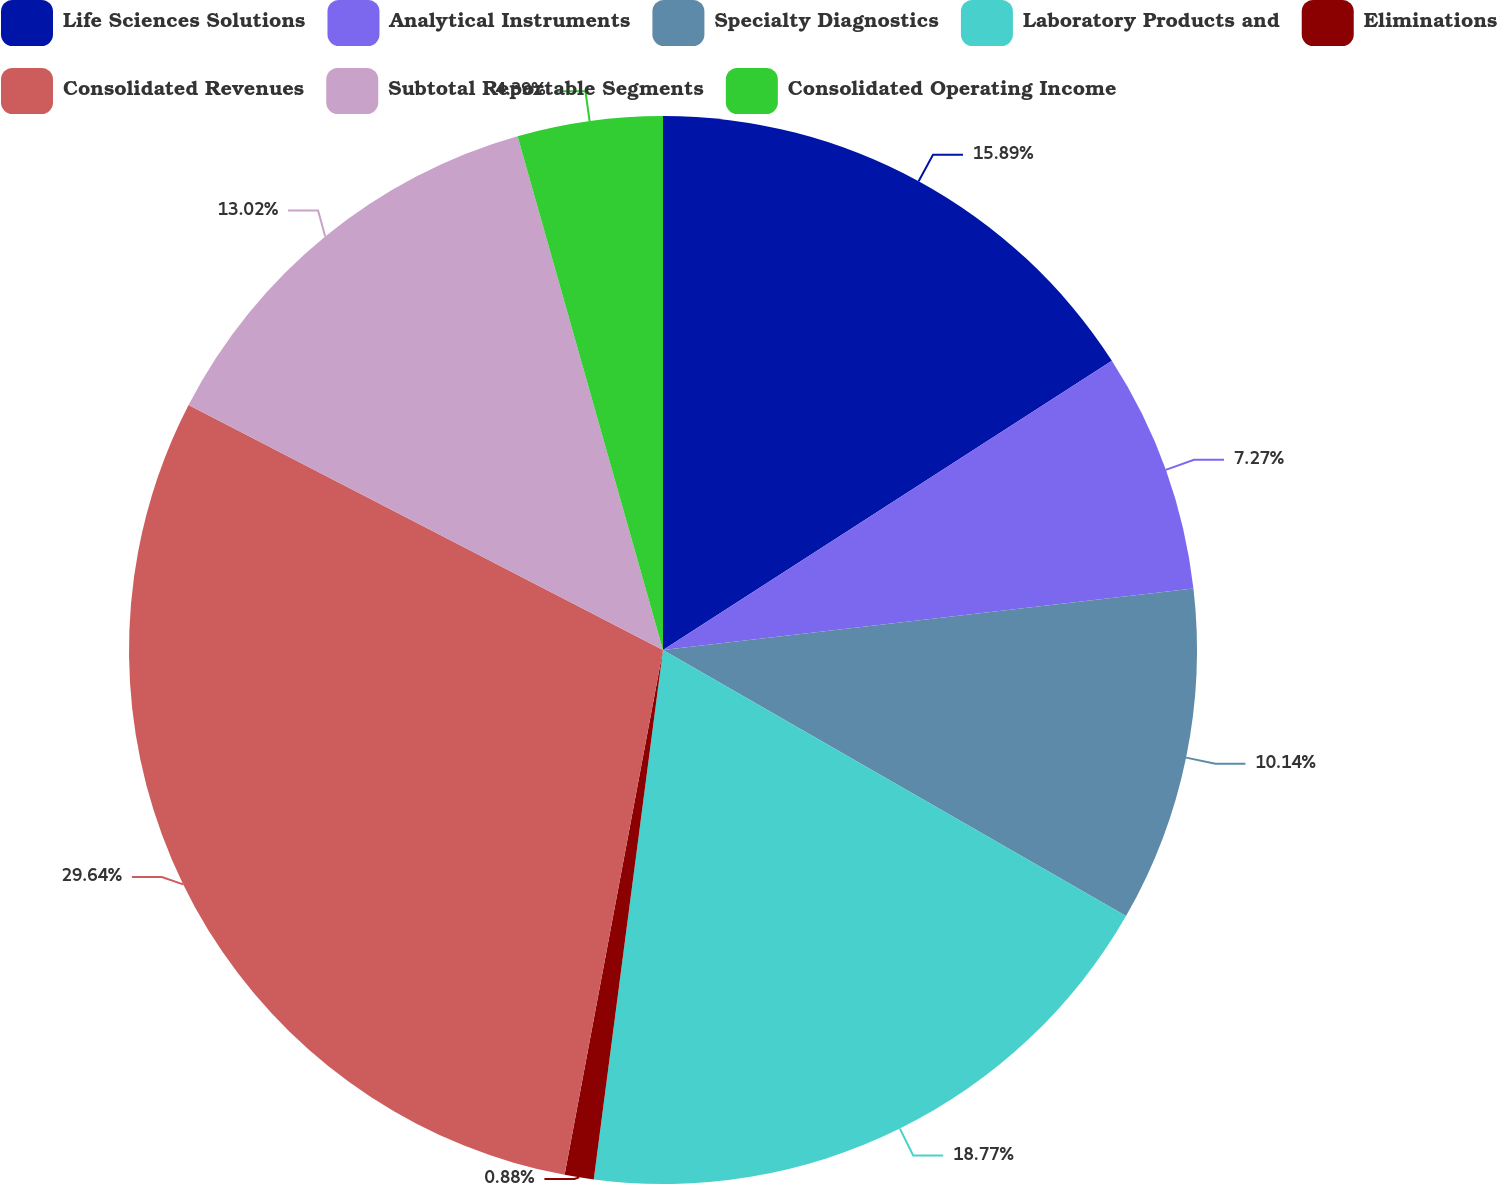Convert chart to OTSL. <chart><loc_0><loc_0><loc_500><loc_500><pie_chart><fcel>Life Sciences Solutions<fcel>Analytical Instruments<fcel>Specialty Diagnostics<fcel>Laboratory Products and<fcel>Eliminations<fcel>Consolidated Revenues<fcel>Subtotal Reportable Segments<fcel>Consolidated Operating Income<nl><fcel>15.89%<fcel>7.27%<fcel>10.14%<fcel>18.77%<fcel>0.88%<fcel>29.64%<fcel>13.02%<fcel>4.39%<nl></chart> 